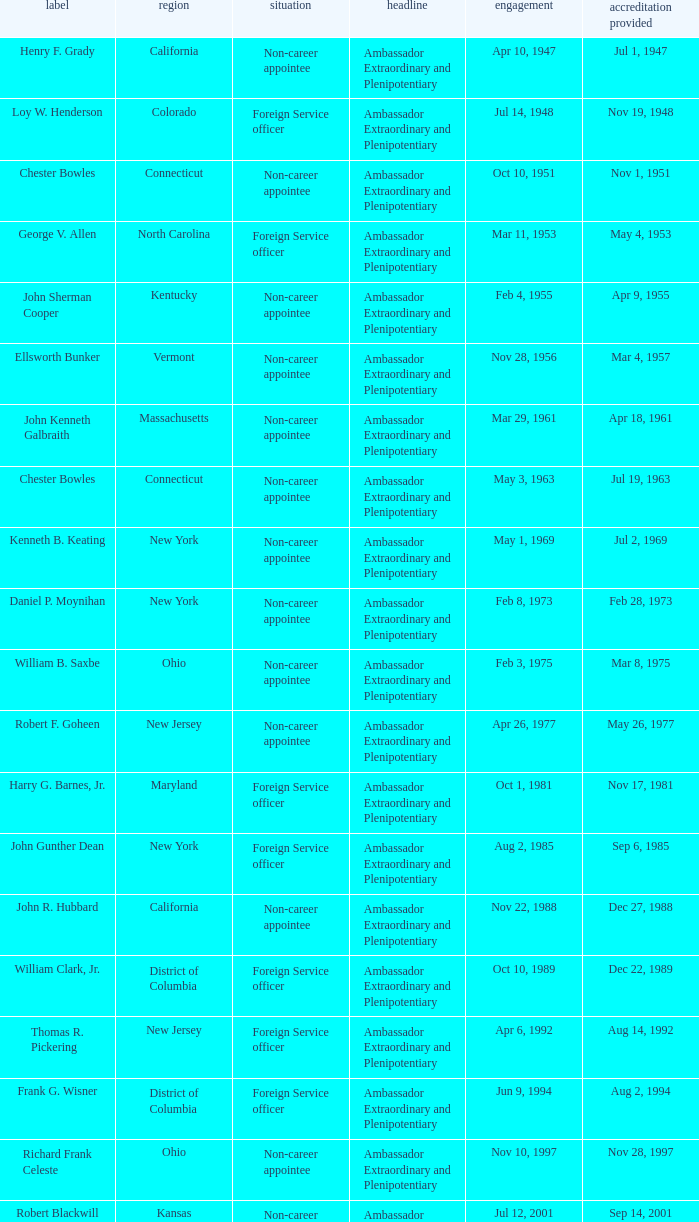What is the title for david campbell mulford? Ambassador Extraordinary and Plenipotentiary. 